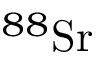Convert formula to latex. <formula><loc_0><loc_0><loc_500><loc_500>^ { 8 8 } S r</formula> 